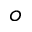<formula> <loc_0><loc_0><loc_500><loc_500>^ { o }</formula> 